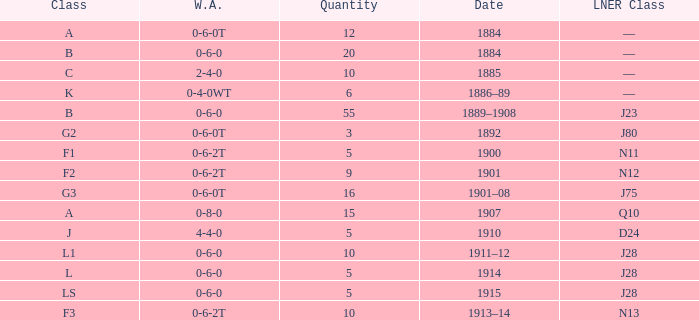What class is associated with a W.A. of 0-8-0? A. 